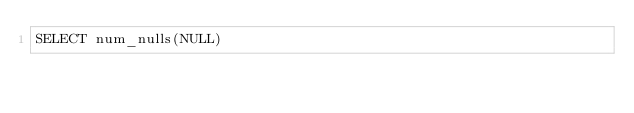Convert code to text. <code><loc_0><loc_0><loc_500><loc_500><_SQL_>SELECT num_nulls(NULL)
</code> 